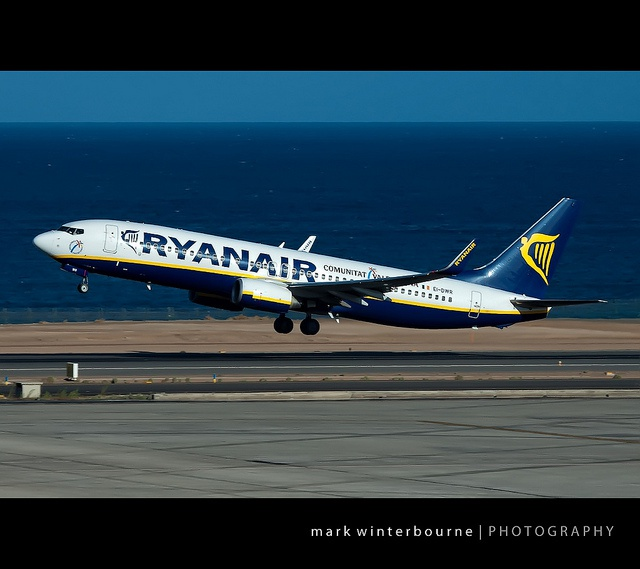Describe the objects in this image and their specific colors. I can see a airplane in black, lightgray, navy, and lightblue tones in this image. 